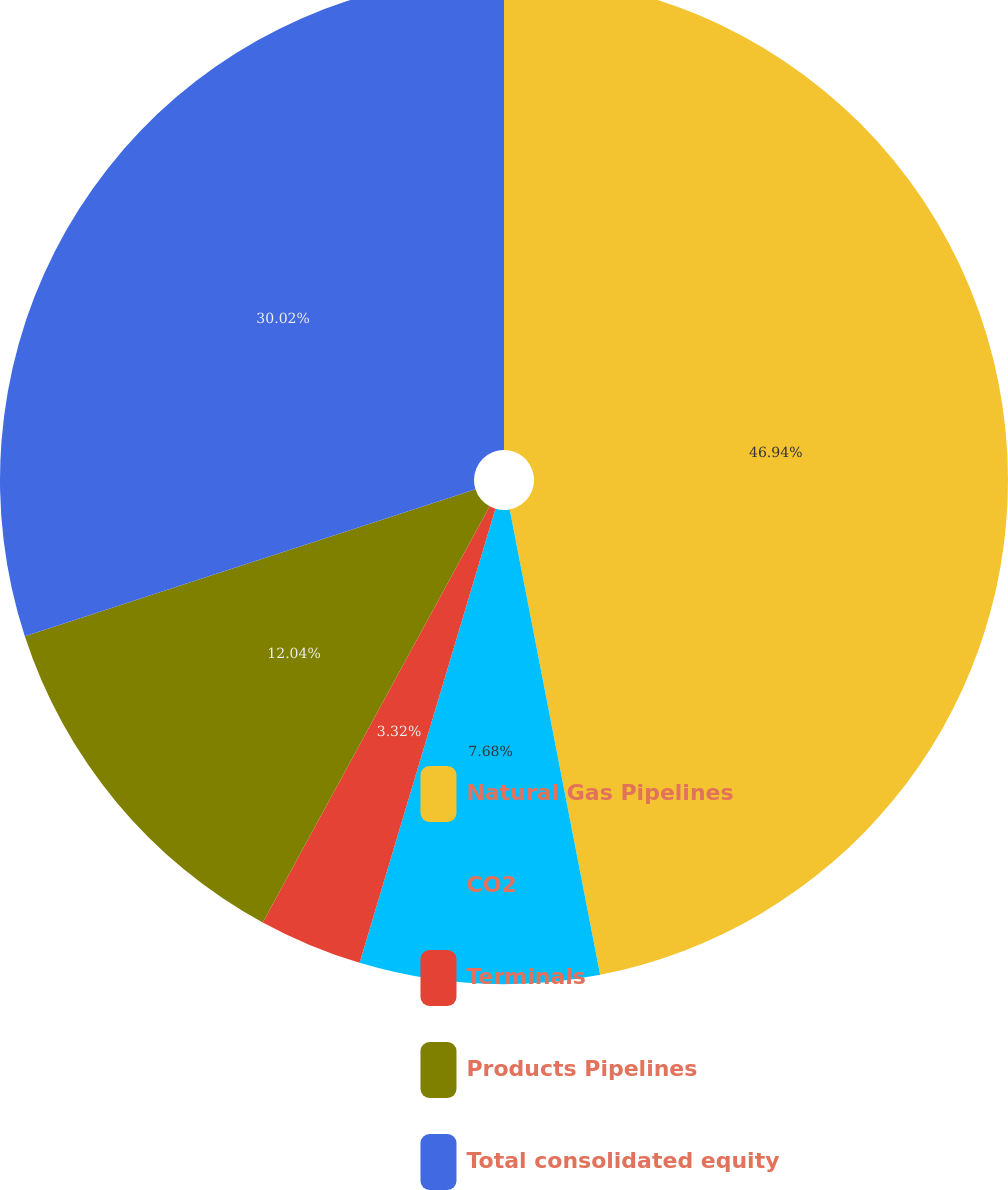Convert chart. <chart><loc_0><loc_0><loc_500><loc_500><pie_chart><fcel>Natural Gas Pipelines<fcel>CO2<fcel>Terminals<fcel>Products Pipelines<fcel>Total consolidated equity<nl><fcel>46.95%<fcel>7.68%<fcel>3.32%<fcel>12.04%<fcel>30.02%<nl></chart> 